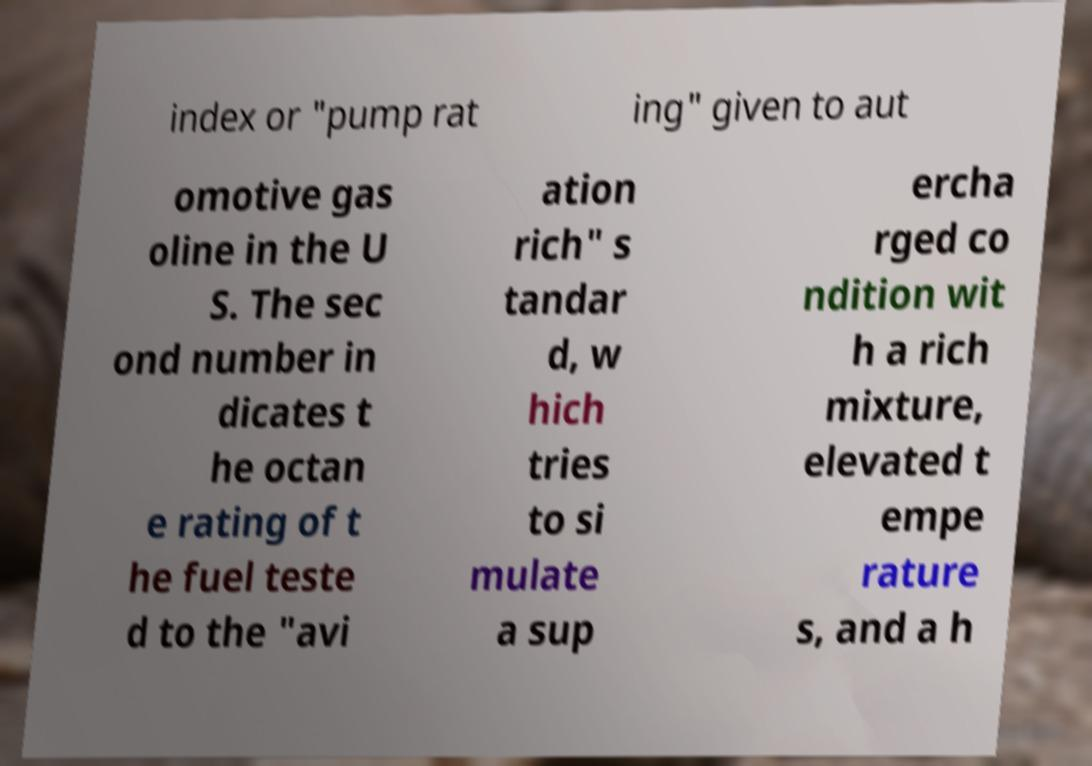Could you extract and type out the text from this image? index or "pump rat ing" given to aut omotive gas oline in the U S. The sec ond number in dicates t he octan e rating of t he fuel teste d to the "avi ation rich" s tandar d, w hich tries to si mulate a sup ercha rged co ndition wit h a rich mixture, elevated t empe rature s, and a h 